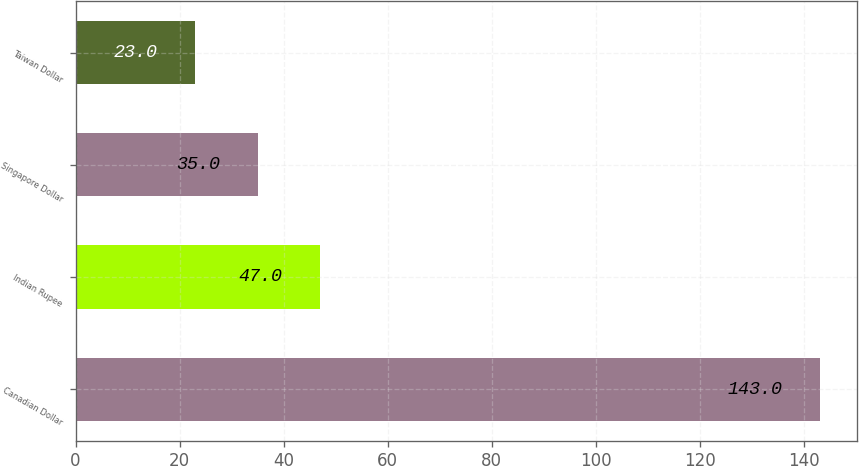<chart> <loc_0><loc_0><loc_500><loc_500><bar_chart><fcel>Canadian Dollar<fcel>Indian Rupee<fcel>Singapore Dollar<fcel>Taiwan Dollar<nl><fcel>143<fcel>47<fcel>35<fcel>23<nl></chart> 